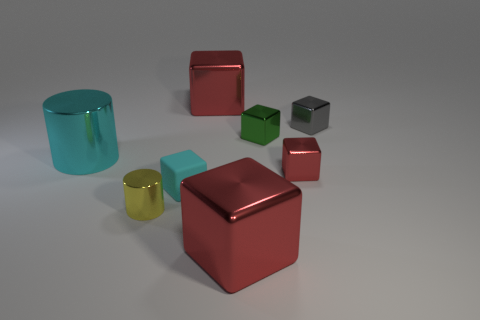Subtract all red blocks. How many were subtracted if there are1red blocks left? 2 Add 1 cyan blocks. How many objects exist? 9 Subtract all gray blocks. How many blocks are left? 5 Subtract all cyan cubes. How many cubes are left? 5 Subtract 3 cubes. How many cubes are left? 3 Subtract all cylinders. How many objects are left? 6 Subtract all brown cubes. Subtract all brown spheres. How many cubes are left? 6 Subtract all cyan blocks. How many gray cylinders are left? 0 Subtract all big metallic blocks. Subtract all green shiny cubes. How many objects are left? 5 Add 1 big shiny objects. How many big shiny objects are left? 4 